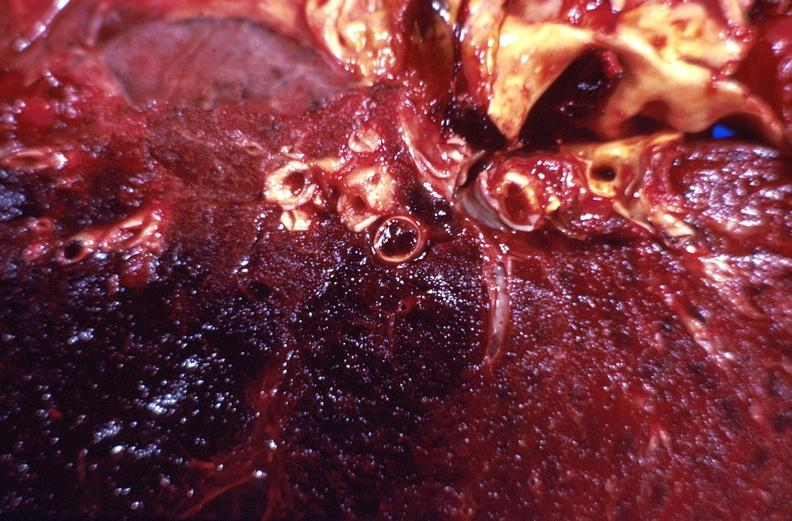s respiratory present?
Answer the question using a single word or phrase. Yes 